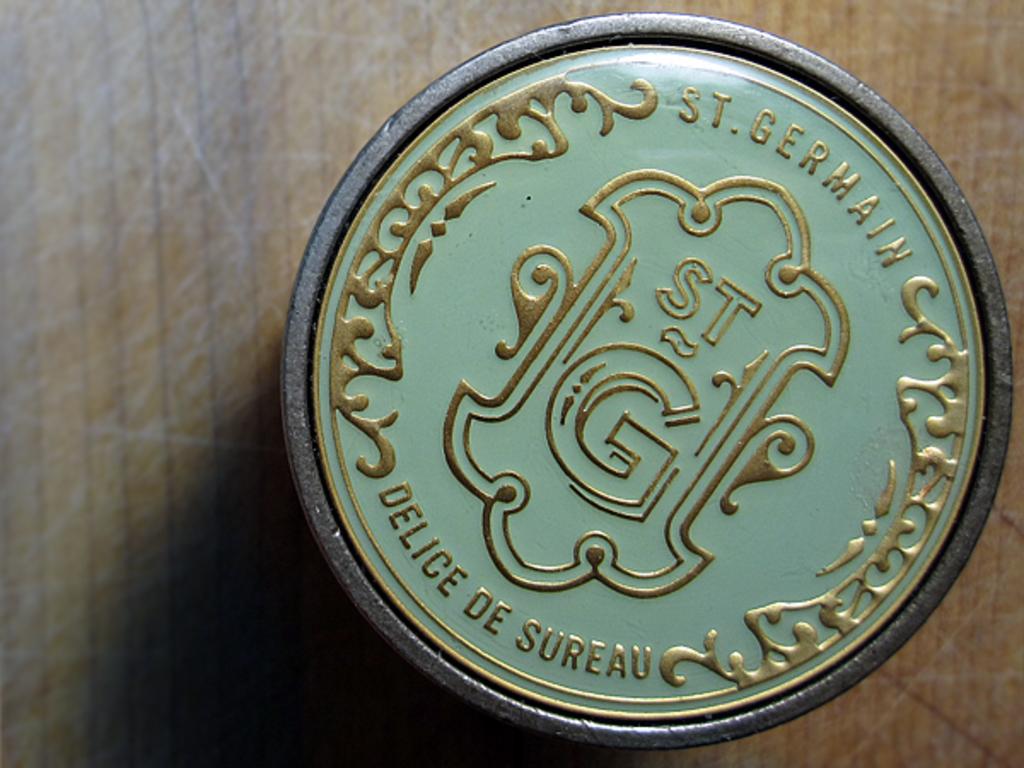What does the coin say at the top?
Give a very brief answer. St. germain. What letters are in the center of the coin?
Give a very brief answer. St g. 